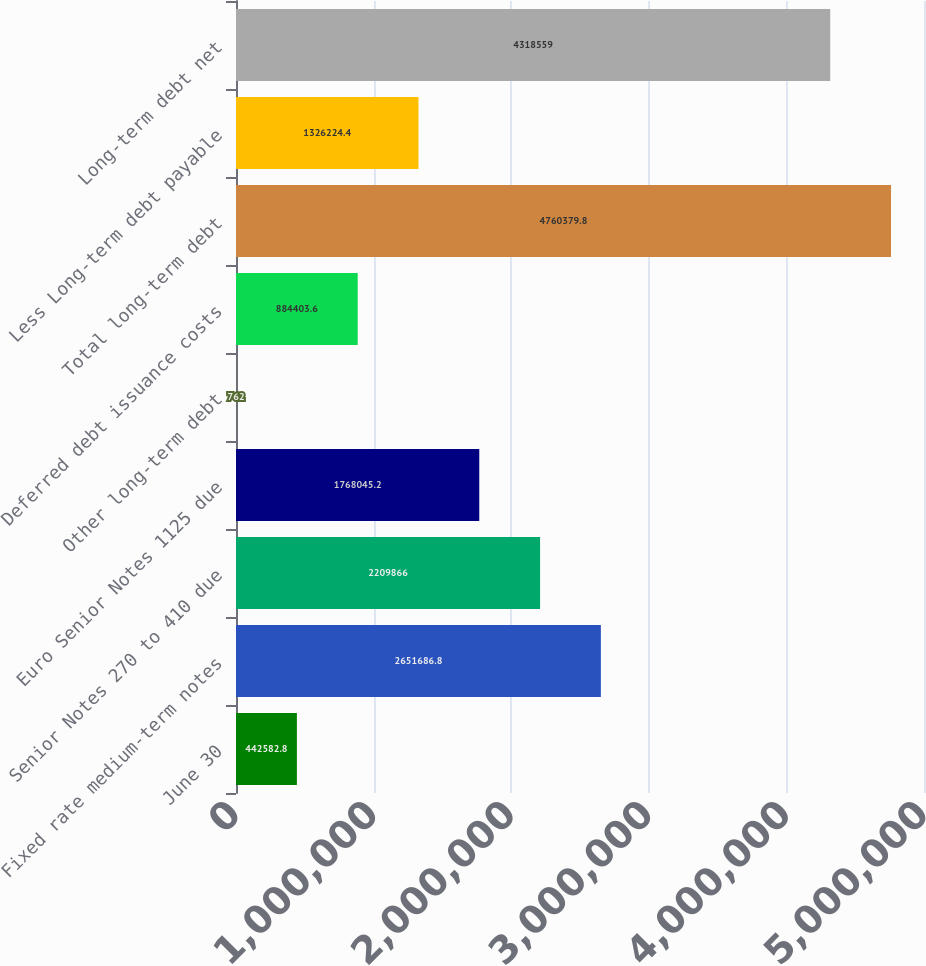<chart> <loc_0><loc_0><loc_500><loc_500><bar_chart><fcel>June 30<fcel>Fixed rate medium-term notes<fcel>Senior Notes 270 to 410 due<fcel>Euro Senior Notes 1125 due<fcel>Other long-term debt<fcel>Deferred debt issuance costs<fcel>Total long-term debt<fcel>Less Long-term debt payable<fcel>Long-term debt net<nl><fcel>442583<fcel>2.65169e+06<fcel>2.20987e+06<fcel>1.76805e+06<fcel>762<fcel>884404<fcel>4.76038e+06<fcel>1.32622e+06<fcel>4.31856e+06<nl></chart> 